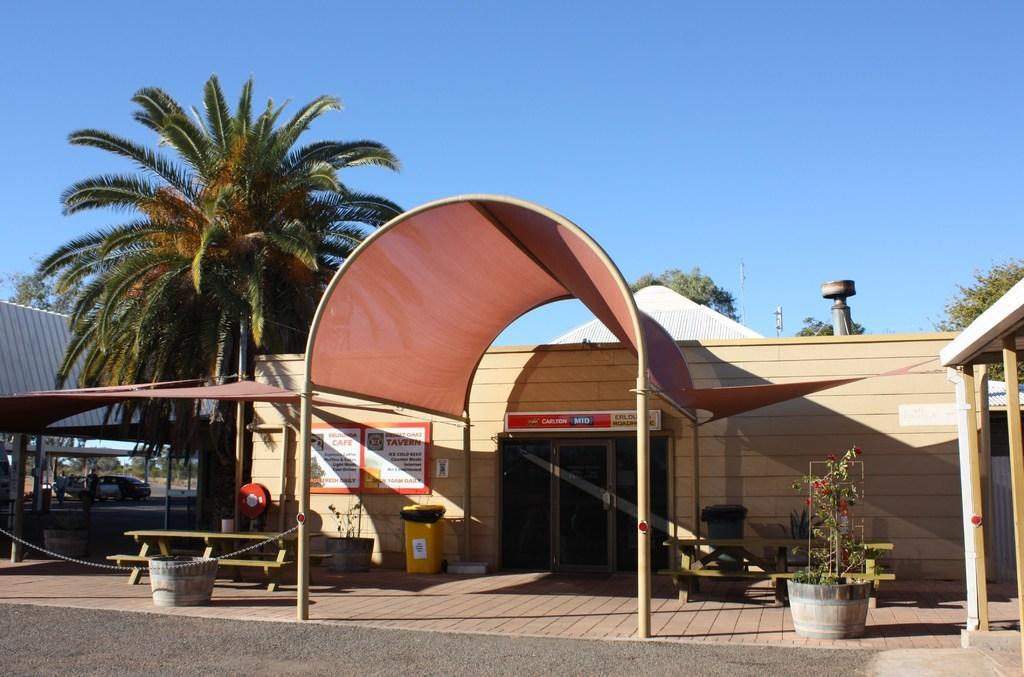Can you describe this image briefly? At the top of the picture we can see a blue sky. these are trees. Here we can see a store , near to the store we can see two trash cans, a bench and a flower pot. We can see cars and persons here. 